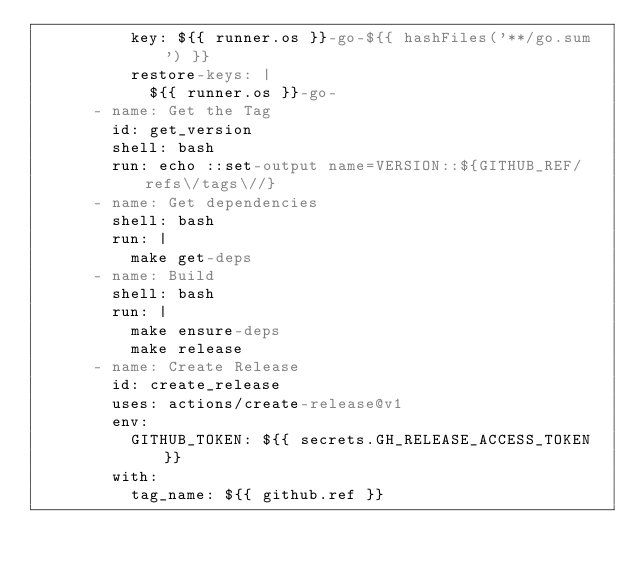Convert code to text. <code><loc_0><loc_0><loc_500><loc_500><_YAML_>          key: ${{ runner.os }}-go-${{ hashFiles('**/go.sum') }}
          restore-keys: |
            ${{ runner.os }}-go-
      - name: Get the Tag
        id: get_version
        shell: bash
        run: echo ::set-output name=VERSION::${GITHUB_REF/refs\/tags\//}
      - name: Get dependencies
        shell: bash
        run: |
          make get-deps
      - name: Build
        shell: bash
        run: |
          make ensure-deps
          make release
      - name: Create Release
        id: create_release
        uses: actions/create-release@v1
        env:
          GITHUB_TOKEN: ${{ secrets.GH_RELEASE_ACCESS_TOKEN }}
        with:
          tag_name: ${{ github.ref }}</code> 